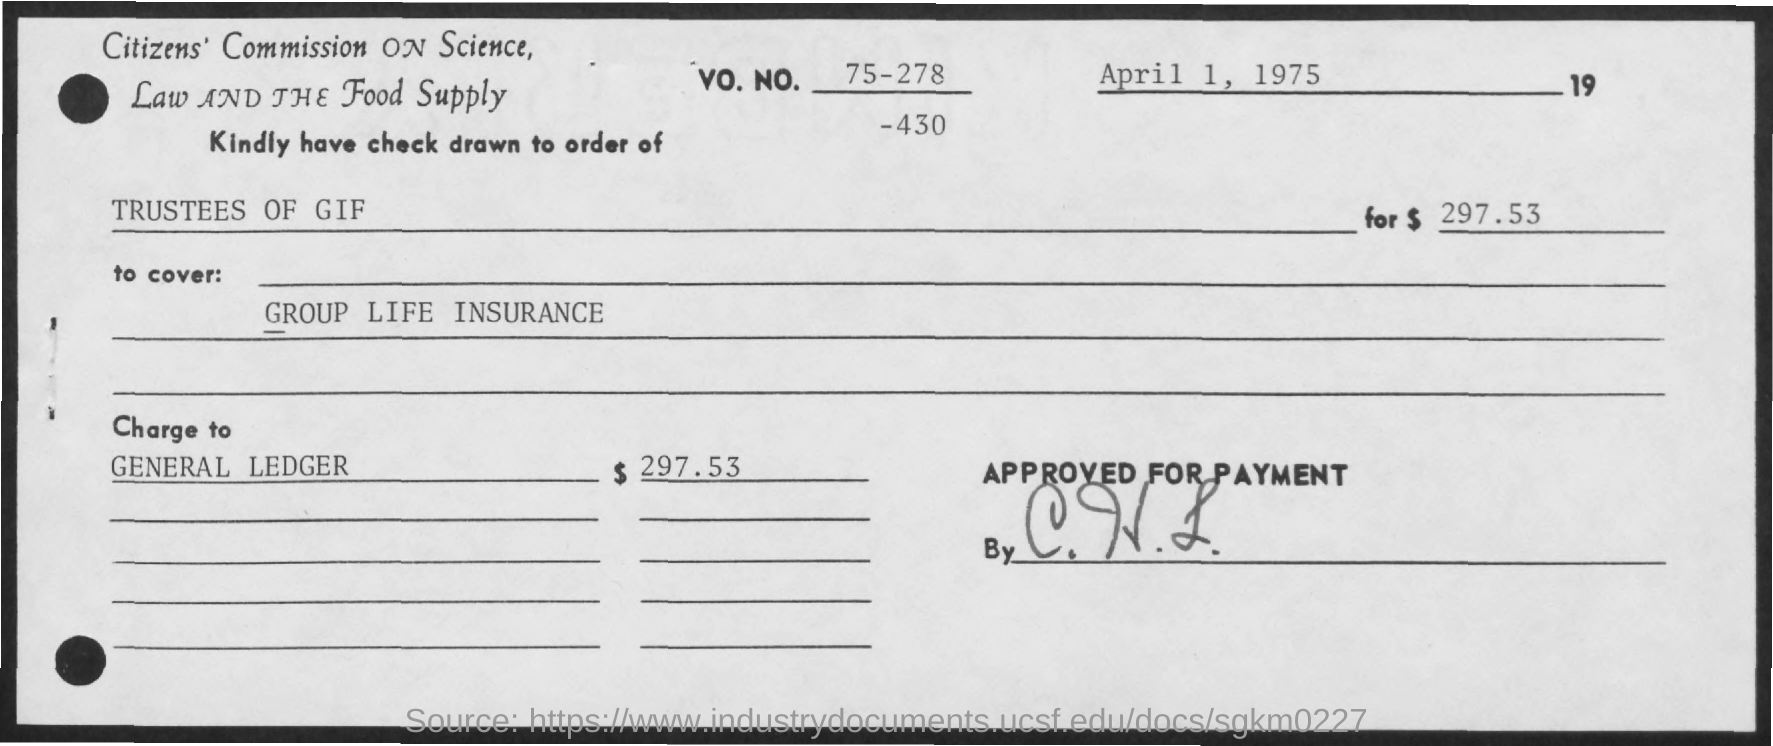What is the date on the document?
Your response must be concise. April 1, 1975. What is the amount?
Ensure brevity in your answer.  $297.53. What is the "Charge to"?
Offer a very short reply. General Ledger. 